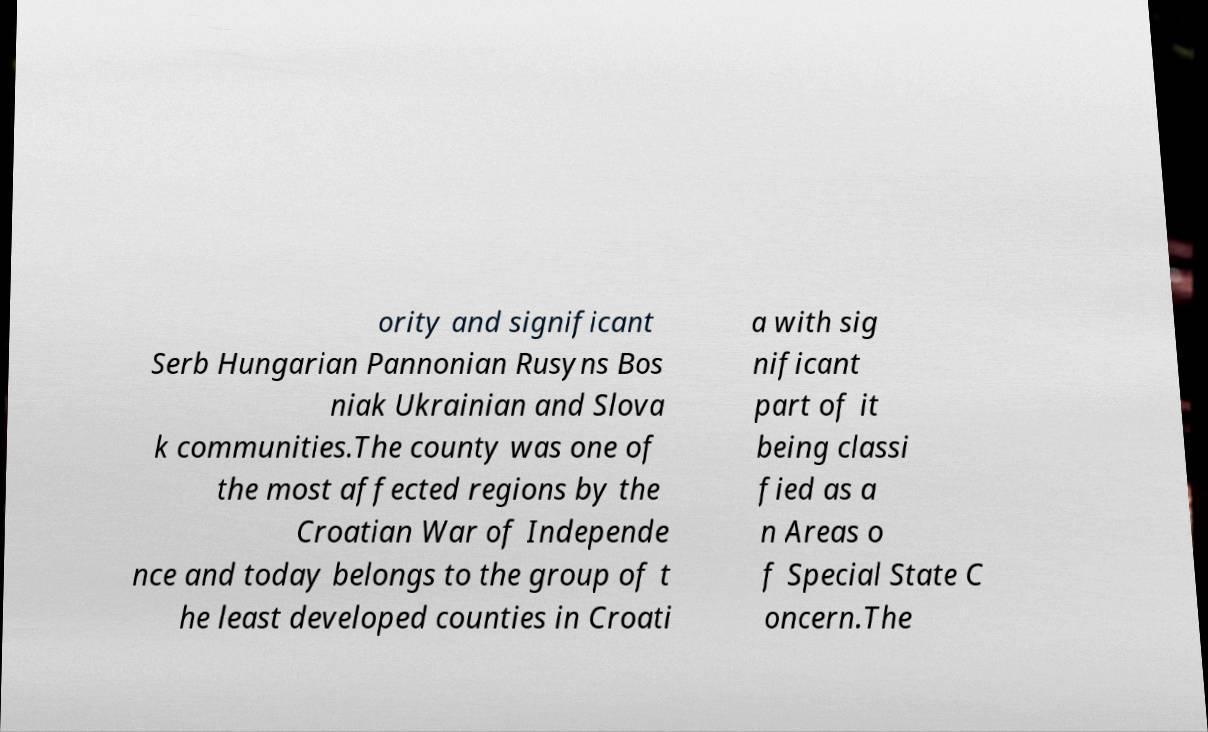There's text embedded in this image that I need extracted. Can you transcribe it verbatim? ority and significant Serb Hungarian Pannonian Rusyns Bos niak Ukrainian and Slova k communities.The county was one of the most affected regions by the Croatian War of Independe nce and today belongs to the group of t he least developed counties in Croati a with sig nificant part of it being classi fied as a n Areas o f Special State C oncern.The 